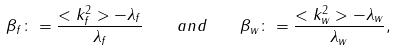Convert formula to latex. <formula><loc_0><loc_0><loc_500><loc_500>\beta _ { f } \colon = \frac { < k _ { f } ^ { 2 } > - \lambda _ { f } } { \lambda _ { f } } \quad a n d \quad \beta _ { w } \colon = \frac { < k _ { w } ^ { 2 } > - \lambda _ { w } } { \lambda _ { w } } ,</formula> 